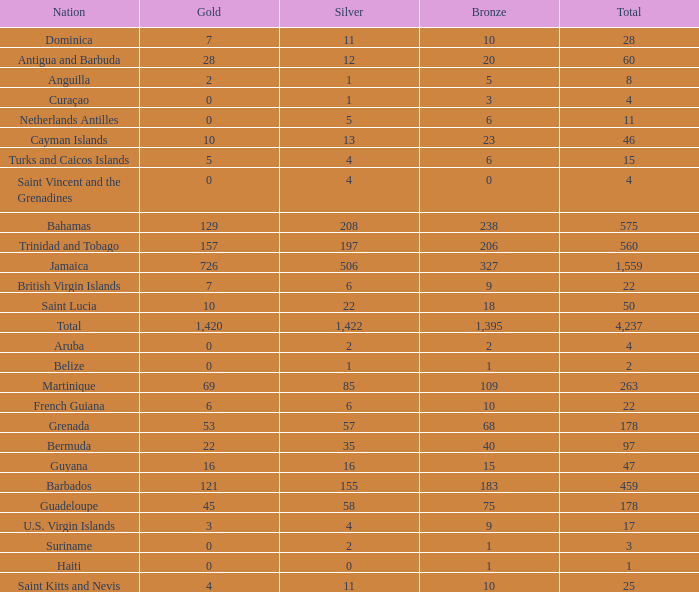What Nation has a Bronze that is smaller than 10 with a Silver of 5? Netherlands Antilles. Could you parse the entire table as a dict? {'header': ['Nation', 'Gold', 'Silver', 'Bronze', 'Total'], 'rows': [['Dominica', '7', '11', '10', '28'], ['Antigua and Barbuda', '28', '12', '20', '60'], ['Anguilla', '2', '1', '5', '8'], ['Curaçao', '0', '1', '3', '4'], ['Netherlands Antilles', '0', '5', '6', '11'], ['Cayman Islands', '10', '13', '23', '46'], ['Turks and Caicos Islands', '5', '4', '6', '15'], ['Saint Vincent and the Grenadines', '0', '4', '0', '4'], ['Bahamas', '129', '208', '238', '575'], ['Trinidad and Tobago', '157', '197', '206', '560'], ['Jamaica', '726', '506', '327', '1,559'], ['British Virgin Islands', '7', '6', '9', '22'], ['Saint Lucia', '10', '22', '18', '50'], ['Total', '1,420', '1,422', '1,395', '4,237'], ['Aruba', '0', '2', '2', '4'], ['Belize', '0', '1', '1', '2'], ['Martinique', '69', '85', '109', '263'], ['French Guiana', '6', '6', '10', '22'], ['Grenada', '53', '57', '68', '178'], ['Bermuda', '22', '35', '40', '97'], ['Guyana', '16', '16', '15', '47'], ['Barbados', '121', '155', '183', '459'], ['Guadeloupe', '45', '58', '75', '178'], ['U.S. Virgin Islands', '3', '4', '9', '17'], ['Suriname', '0', '2', '1', '3'], ['Haiti', '0', '0', '1', '1'], ['Saint Kitts and Nevis', '4', '11', '10', '25']]} 